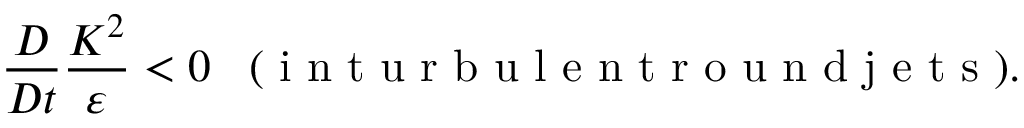<formula> <loc_0><loc_0><loc_500><loc_500>\frac { D } { D t } \frac { K ^ { 2 } } { \varepsilon } < 0 \, ( i n t u r b u l e n t r o u n d j e t s ) .</formula> 